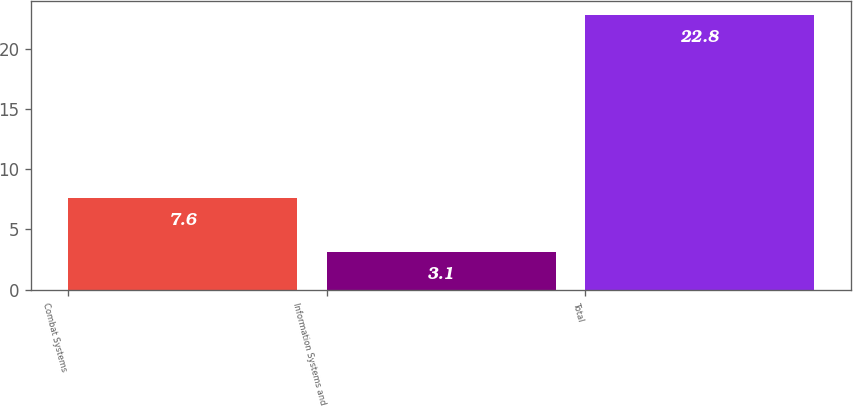Convert chart. <chart><loc_0><loc_0><loc_500><loc_500><bar_chart><fcel>Combat Systems<fcel>Information Systems and<fcel>Total<nl><fcel>7.6<fcel>3.1<fcel>22.8<nl></chart> 